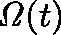<formula> <loc_0><loc_0><loc_500><loc_500>\Omega ( t )</formula> 